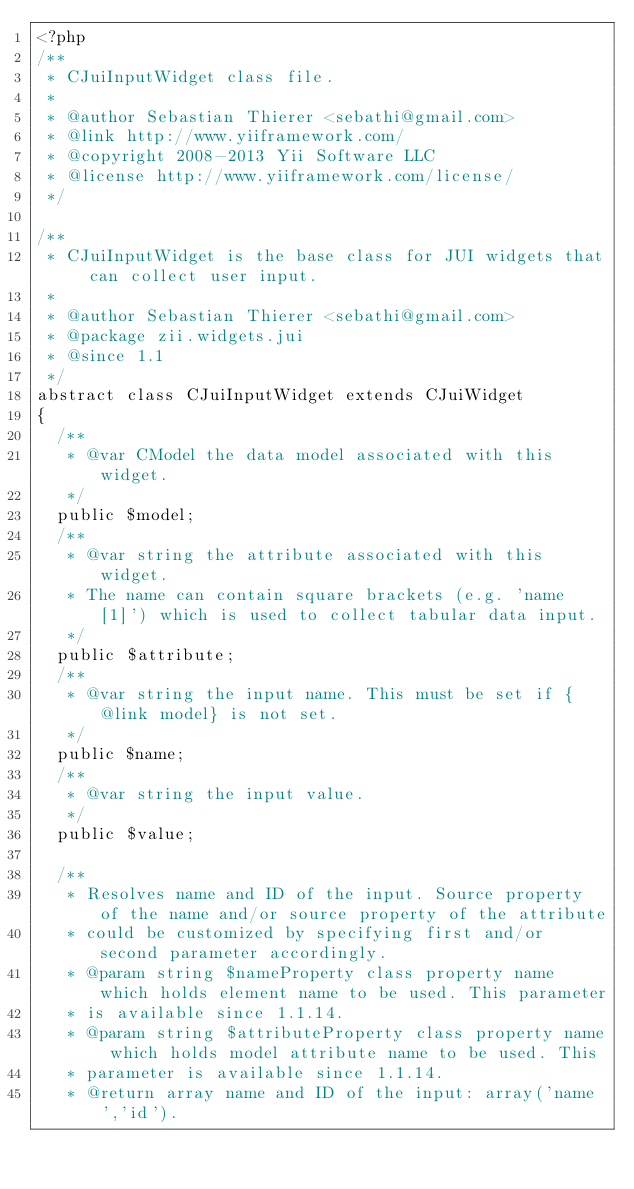<code> <loc_0><loc_0><loc_500><loc_500><_PHP_><?php
/**
 * CJuiInputWidget class file.
 *
 * @author Sebastian Thierer <sebathi@gmail.com>
 * @link http://www.yiiframework.com/
 * @copyright 2008-2013 Yii Software LLC
 * @license http://www.yiiframework.com/license/
 */

/**
 * CJuiInputWidget is the base class for JUI widgets that can collect user input.
 *
 * @author Sebastian Thierer <sebathi@gmail.com>
 * @package zii.widgets.jui
 * @since 1.1
 */
abstract class CJuiInputWidget extends CJuiWidget
{
	/**
	 * @var CModel the data model associated with this widget.
	 */
	public $model;
	/**
	 * @var string the attribute associated with this widget.
	 * The name can contain square brackets (e.g. 'name[1]') which is used to collect tabular data input.
	 */
	public $attribute;
	/**
	 * @var string the input name. This must be set if {@link model} is not set.
	 */
	public $name;
	/**
	 * @var string the input value.
	 */
	public $value;

	/**
	 * Resolves name and ID of the input. Source property of the name and/or source property of the attribute
	 * could be customized by specifying first and/or second parameter accordingly.
	 * @param string $nameProperty class property name which holds element name to be used. This parameter
	 * is available since 1.1.14.
	 * @param string $attributeProperty class property name which holds model attribute name to be used. This
	 * parameter is available since 1.1.14.
	 * @return array name and ID of the input: array('name','id').</code> 